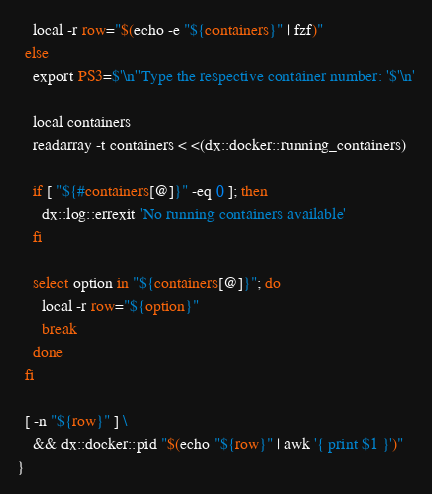<code> <loc_0><loc_0><loc_500><loc_500><_Bash_>
    local -r row="$(echo -e "${containers}" | fzf)"
  else
    export PS3=$'\n''Type the respective container number: '$'\n'

    local containers
    readarray -t containers < <(dx::docker::running_containers)

    if [ "${#containers[@]}" -eq 0 ]; then
      dx::log::errexit 'No running containers available'
    fi

    select option in "${containers[@]}"; do
      local -r row="${option}"
      break
    done
  fi

  [ -n "${row}" ] \
    && dx::docker::pid "$(echo "${row}" | awk '{ print $1 }')"
}
</code> 